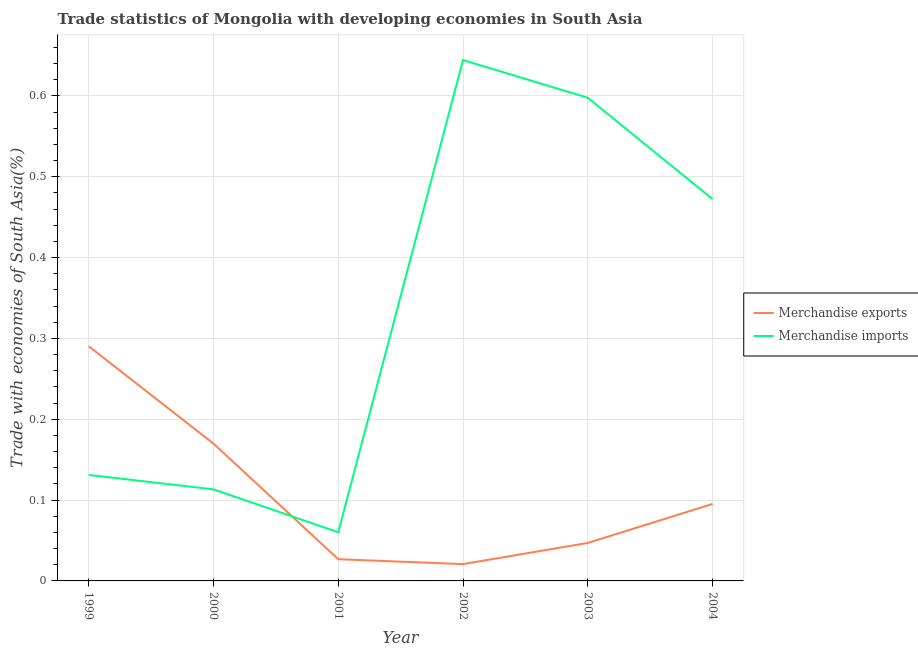Does the line corresponding to merchandise imports intersect with the line corresponding to merchandise exports?
Make the answer very short. Yes. Is the number of lines equal to the number of legend labels?
Provide a short and direct response. Yes. What is the merchandise exports in 2000?
Keep it short and to the point. 0.17. Across all years, what is the maximum merchandise imports?
Offer a terse response. 0.64. Across all years, what is the minimum merchandise imports?
Provide a succinct answer. 0.06. In which year was the merchandise exports maximum?
Your response must be concise. 1999. What is the total merchandise imports in the graph?
Make the answer very short. 2.02. What is the difference between the merchandise imports in 2001 and that in 2004?
Your answer should be compact. -0.41. What is the difference between the merchandise exports in 2003 and the merchandise imports in 2002?
Make the answer very short. -0.6. What is the average merchandise exports per year?
Offer a very short reply. 0.11. In the year 2002, what is the difference between the merchandise imports and merchandise exports?
Give a very brief answer. 0.62. In how many years, is the merchandise exports greater than 0.1 %?
Your response must be concise. 2. What is the ratio of the merchandise exports in 2001 to that in 2003?
Offer a very short reply. 0.57. Is the merchandise exports in 2001 less than that in 2003?
Your response must be concise. Yes. What is the difference between the highest and the second highest merchandise imports?
Provide a short and direct response. 0.05. What is the difference between the highest and the lowest merchandise exports?
Ensure brevity in your answer.  0.27. In how many years, is the merchandise exports greater than the average merchandise exports taken over all years?
Offer a terse response. 2. What is the difference between two consecutive major ticks on the Y-axis?
Make the answer very short. 0.1. Where does the legend appear in the graph?
Your answer should be very brief. Center right. How are the legend labels stacked?
Your response must be concise. Vertical. What is the title of the graph?
Give a very brief answer. Trade statistics of Mongolia with developing economies in South Asia. What is the label or title of the X-axis?
Give a very brief answer. Year. What is the label or title of the Y-axis?
Offer a terse response. Trade with economies of South Asia(%). What is the Trade with economies of South Asia(%) of Merchandise exports in 1999?
Keep it short and to the point. 0.29. What is the Trade with economies of South Asia(%) of Merchandise imports in 1999?
Offer a terse response. 0.13. What is the Trade with economies of South Asia(%) of Merchandise exports in 2000?
Your answer should be very brief. 0.17. What is the Trade with economies of South Asia(%) of Merchandise imports in 2000?
Ensure brevity in your answer.  0.11. What is the Trade with economies of South Asia(%) in Merchandise exports in 2001?
Make the answer very short. 0.03. What is the Trade with economies of South Asia(%) in Merchandise imports in 2001?
Provide a succinct answer. 0.06. What is the Trade with economies of South Asia(%) of Merchandise exports in 2002?
Provide a short and direct response. 0.02. What is the Trade with economies of South Asia(%) of Merchandise imports in 2002?
Your answer should be compact. 0.64. What is the Trade with economies of South Asia(%) of Merchandise exports in 2003?
Give a very brief answer. 0.05. What is the Trade with economies of South Asia(%) of Merchandise imports in 2003?
Make the answer very short. 0.6. What is the Trade with economies of South Asia(%) in Merchandise exports in 2004?
Ensure brevity in your answer.  0.1. What is the Trade with economies of South Asia(%) in Merchandise imports in 2004?
Make the answer very short. 0.47. Across all years, what is the maximum Trade with economies of South Asia(%) of Merchandise exports?
Provide a short and direct response. 0.29. Across all years, what is the maximum Trade with economies of South Asia(%) in Merchandise imports?
Give a very brief answer. 0.64. Across all years, what is the minimum Trade with economies of South Asia(%) in Merchandise exports?
Provide a short and direct response. 0.02. Across all years, what is the minimum Trade with economies of South Asia(%) of Merchandise imports?
Offer a very short reply. 0.06. What is the total Trade with economies of South Asia(%) in Merchandise exports in the graph?
Your response must be concise. 0.65. What is the total Trade with economies of South Asia(%) of Merchandise imports in the graph?
Keep it short and to the point. 2.02. What is the difference between the Trade with economies of South Asia(%) of Merchandise exports in 1999 and that in 2000?
Offer a terse response. 0.12. What is the difference between the Trade with economies of South Asia(%) of Merchandise imports in 1999 and that in 2000?
Your response must be concise. 0.02. What is the difference between the Trade with economies of South Asia(%) in Merchandise exports in 1999 and that in 2001?
Offer a very short reply. 0.26. What is the difference between the Trade with economies of South Asia(%) in Merchandise imports in 1999 and that in 2001?
Make the answer very short. 0.07. What is the difference between the Trade with economies of South Asia(%) of Merchandise exports in 1999 and that in 2002?
Give a very brief answer. 0.27. What is the difference between the Trade with economies of South Asia(%) of Merchandise imports in 1999 and that in 2002?
Make the answer very short. -0.51. What is the difference between the Trade with economies of South Asia(%) in Merchandise exports in 1999 and that in 2003?
Give a very brief answer. 0.24. What is the difference between the Trade with economies of South Asia(%) of Merchandise imports in 1999 and that in 2003?
Your response must be concise. -0.47. What is the difference between the Trade with economies of South Asia(%) of Merchandise exports in 1999 and that in 2004?
Ensure brevity in your answer.  0.2. What is the difference between the Trade with economies of South Asia(%) in Merchandise imports in 1999 and that in 2004?
Provide a succinct answer. -0.34. What is the difference between the Trade with economies of South Asia(%) of Merchandise exports in 2000 and that in 2001?
Provide a succinct answer. 0.14. What is the difference between the Trade with economies of South Asia(%) of Merchandise imports in 2000 and that in 2001?
Offer a terse response. 0.05. What is the difference between the Trade with economies of South Asia(%) of Merchandise exports in 2000 and that in 2002?
Give a very brief answer. 0.15. What is the difference between the Trade with economies of South Asia(%) in Merchandise imports in 2000 and that in 2002?
Offer a very short reply. -0.53. What is the difference between the Trade with economies of South Asia(%) of Merchandise exports in 2000 and that in 2003?
Provide a succinct answer. 0.12. What is the difference between the Trade with economies of South Asia(%) in Merchandise imports in 2000 and that in 2003?
Provide a succinct answer. -0.48. What is the difference between the Trade with economies of South Asia(%) in Merchandise exports in 2000 and that in 2004?
Offer a terse response. 0.07. What is the difference between the Trade with economies of South Asia(%) in Merchandise imports in 2000 and that in 2004?
Keep it short and to the point. -0.36. What is the difference between the Trade with economies of South Asia(%) in Merchandise exports in 2001 and that in 2002?
Keep it short and to the point. 0.01. What is the difference between the Trade with economies of South Asia(%) of Merchandise imports in 2001 and that in 2002?
Your response must be concise. -0.58. What is the difference between the Trade with economies of South Asia(%) of Merchandise exports in 2001 and that in 2003?
Provide a succinct answer. -0.02. What is the difference between the Trade with economies of South Asia(%) in Merchandise imports in 2001 and that in 2003?
Offer a terse response. -0.54. What is the difference between the Trade with economies of South Asia(%) of Merchandise exports in 2001 and that in 2004?
Provide a short and direct response. -0.07. What is the difference between the Trade with economies of South Asia(%) in Merchandise imports in 2001 and that in 2004?
Your response must be concise. -0.41. What is the difference between the Trade with economies of South Asia(%) in Merchandise exports in 2002 and that in 2003?
Give a very brief answer. -0.03. What is the difference between the Trade with economies of South Asia(%) of Merchandise imports in 2002 and that in 2003?
Ensure brevity in your answer.  0.05. What is the difference between the Trade with economies of South Asia(%) of Merchandise exports in 2002 and that in 2004?
Make the answer very short. -0.07. What is the difference between the Trade with economies of South Asia(%) of Merchandise imports in 2002 and that in 2004?
Give a very brief answer. 0.17. What is the difference between the Trade with economies of South Asia(%) of Merchandise exports in 2003 and that in 2004?
Make the answer very short. -0.05. What is the difference between the Trade with economies of South Asia(%) in Merchandise imports in 2003 and that in 2004?
Offer a very short reply. 0.13. What is the difference between the Trade with economies of South Asia(%) in Merchandise exports in 1999 and the Trade with economies of South Asia(%) in Merchandise imports in 2000?
Provide a short and direct response. 0.18. What is the difference between the Trade with economies of South Asia(%) in Merchandise exports in 1999 and the Trade with economies of South Asia(%) in Merchandise imports in 2001?
Your answer should be very brief. 0.23. What is the difference between the Trade with economies of South Asia(%) in Merchandise exports in 1999 and the Trade with economies of South Asia(%) in Merchandise imports in 2002?
Offer a terse response. -0.35. What is the difference between the Trade with economies of South Asia(%) of Merchandise exports in 1999 and the Trade with economies of South Asia(%) of Merchandise imports in 2003?
Your answer should be very brief. -0.31. What is the difference between the Trade with economies of South Asia(%) in Merchandise exports in 1999 and the Trade with economies of South Asia(%) in Merchandise imports in 2004?
Keep it short and to the point. -0.18. What is the difference between the Trade with economies of South Asia(%) of Merchandise exports in 2000 and the Trade with economies of South Asia(%) of Merchandise imports in 2001?
Your answer should be compact. 0.11. What is the difference between the Trade with economies of South Asia(%) of Merchandise exports in 2000 and the Trade with economies of South Asia(%) of Merchandise imports in 2002?
Offer a terse response. -0.47. What is the difference between the Trade with economies of South Asia(%) of Merchandise exports in 2000 and the Trade with economies of South Asia(%) of Merchandise imports in 2003?
Ensure brevity in your answer.  -0.43. What is the difference between the Trade with economies of South Asia(%) in Merchandise exports in 2000 and the Trade with economies of South Asia(%) in Merchandise imports in 2004?
Your answer should be compact. -0.3. What is the difference between the Trade with economies of South Asia(%) of Merchandise exports in 2001 and the Trade with economies of South Asia(%) of Merchandise imports in 2002?
Offer a very short reply. -0.62. What is the difference between the Trade with economies of South Asia(%) of Merchandise exports in 2001 and the Trade with economies of South Asia(%) of Merchandise imports in 2003?
Provide a short and direct response. -0.57. What is the difference between the Trade with economies of South Asia(%) of Merchandise exports in 2001 and the Trade with economies of South Asia(%) of Merchandise imports in 2004?
Offer a very short reply. -0.45. What is the difference between the Trade with economies of South Asia(%) of Merchandise exports in 2002 and the Trade with economies of South Asia(%) of Merchandise imports in 2003?
Your response must be concise. -0.58. What is the difference between the Trade with economies of South Asia(%) in Merchandise exports in 2002 and the Trade with economies of South Asia(%) in Merchandise imports in 2004?
Your answer should be very brief. -0.45. What is the difference between the Trade with economies of South Asia(%) in Merchandise exports in 2003 and the Trade with economies of South Asia(%) in Merchandise imports in 2004?
Make the answer very short. -0.43. What is the average Trade with economies of South Asia(%) of Merchandise exports per year?
Keep it short and to the point. 0.11. What is the average Trade with economies of South Asia(%) of Merchandise imports per year?
Your response must be concise. 0.34. In the year 1999, what is the difference between the Trade with economies of South Asia(%) of Merchandise exports and Trade with economies of South Asia(%) of Merchandise imports?
Give a very brief answer. 0.16. In the year 2000, what is the difference between the Trade with economies of South Asia(%) of Merchandise exports and Trade with economies of South Asia(%) of Merchandise imports?
Provide a short and direct response. 0.06. In the year 2001, what is the difference between the Trade with economies of South Asia(%) in Merchandise exports and Trade with economies of South Asia(%) in Merchandise imports?
Offer a very short reply. -0.03. In the year 2002, what is the difference between the Trade with economies of South Asia(%) in Merchandise exports and Trade with economies of South Asia(%) in Merchandise imports?
Your response must be concise. -0.62. In the year 2003, what is the difference between the Trade with economies of South Asia(%) of Merchandise exports and Trade with economies of South Asia(%) of Merchandise imports?
Your response must be concise. -0.55. In the year 2004, what is the difference between the Trade with economies of South Asia(%) in Merchandise exports and Trade with economies of South Asia(%) in Merchandise imports?
Keep it short and to the point. -0.38. What is the ratio of the Trade with economies of South Asia(%) in Merchandise exports in 1999 to that in 2000?
Your response must be concise. 1.71. What is the ratio of the Trade with economies of South Asia(%) of Merchandise imports in 1999 to that in 2000?
Your response must be concise. 1.16. What is the ratio of the Trade with economies of South Asia(%) in Merchandise exports in 1999 to that in 2001?
Make the answer very short. 10.81. What is the ratio of the Trade with economies of South Asia(%) in Merchandise imports in 1999 to that in 2001?
Make the answer very short. 2.18. What is the ratio of the Trade with economies of South Asia(%) in Merchandise exports in 1999 to that in 2002?
Offer a very short reply. 13.95. What is the ratio of the Trade with economies of South Asia(%) in Merchandise imports in 1999 to that in 2002?
Your response must be concise. 0.2. What is the ratio of the Trade with economies of South Asia(%) of Merchandise exports in 1999 to that in 2003?
Keep it short and to the point. 6.18. What is the ratio of the Trade with economies of South Asia(%) in Merchandise imports in 1999 to that in 2003?
Offer a very short reply. 0.22. What is the ratio of the Trade with economies of South Asia(%) in Merchandise exports in 1999 to that in 2004?
Keep it short and to the point. 3.05. What is the ratio of the Trade with economies of South Asia(%) of Merchandise imports in 1999 to that in 2004?
Offer a very short reply. 0.28. What is the ratio of the Trade with economies of South Asia(%) in Merchandise exports in 2000 to that in 2001?
Offer a terse response. 6.32. What is the ratio of the Trade with economies of South Asia(%) of Merchandise imports in 2000 to that in 2001?
Provide a short and direct response. 1.88. What is the ratio of the Trade with economies of South Asia(%) in Merchandise exports in 2000 to that in 2002?
Your answer should be compact. 8.16. What is the ratio of the Trade with economies of South Asia(%) of Merchandise imports in 2000 to that in 2002?
Your answer should be compact. 0.18. What is the ratio of the Trade with economies of South Asia(%) of Merchandise exports in 2000 to that in 2003?
Offer a very short reply. 3.62. What is the ratio of the Trade with economies of South Asia(%) in Merchandise imports in 2000 to that in 2003?
Your response must be concise. 0.19. What is the ratio of the Trade with economies of South Asia(%) of Merchandise exports in 2000 to that in 2004?
Provide a short and direct response. 1.78. What is the ratio of the Trade with economies of South Asia(%) of Merchandise imports in 2000 to that in 2004?
Provide a succinct answer. 0.24. What is the ratio of the Trade with economies of South Asia(%) in Merchandise exports in 2001 to that in 2002?
Your answer should be compact. 1.29. What is the ratio of the Trade with economies of South Asia(%) in Merchandise imports in 2001 to that in 2002?
Your response must be concise. 0.09. What is the ratio of the Trade with economies of South Asia(%) in Merchandise exports in 2001 to that in 2003?
Your answer should be compact. 0.57. What is the ratio of the Trade with economies of South Asia(%) of Merchandise imports in 2001 to that in 2003?
Provide a succinct answer. 0.1. What is the ratio of the Trade with economies of South Asia(%) in Merchandise exports in 2001 to that in 2004?
Ensure brevity in your answer.  0.28. What is the ratio of the Trade with economies of South Asia(%) in Merchandise imports in 2001 to that in 2004?
Provide a succinct answer. 0.13. What is the ratio of the Trade with economies of South Asia(%) in Merchandise exports in 2002 to that in 2003?
Your response must be concise. 0.44. What is the ratio of the Trade with economies of South Asia(%) in Merchandise imports in 2002 to that in 2003?
Offer a very short reply. 1.08. What is the ratio of the Trade with economies of South Asia(%) in Merchandise exports in 2002 to that in 2004?
Your response must be concise. 0.22. What is the ratio of the Trade with economies of South Asia(%) of Merchandise imports in 2002 to that in 2004?
Offer a terse response. 1.36. What is the ratio of the Trade with economies of South Asia(%) in Merchandise exports in 2003 to that in 2004?
Offer a terse response. 0.49. What is the ratio of the Trade with economies of South Asia(%) in Merchandise imports in 2003 to that in 2004?
Your answer should be compact. 1.27. What is the difference between the highest and the second highest Trade with economies of South Asia(%) of Merchandise exports?
Your answer should be compact. 0.12. What is the difference between the highest and the second highest Trade with economies of South Asia(%) of Merchandise imports?
Make the answer very short. 0.05. What is the difference between the highest and the lowest Trade with economies of South Asia(%) of Merchandise exports?
Ensure brevity in your answer.  0.27. What is the difference between the highest and the lowest Trade with economies of South Asia(%) of Merchandise imports?
Make the answer very short. 0.58. 